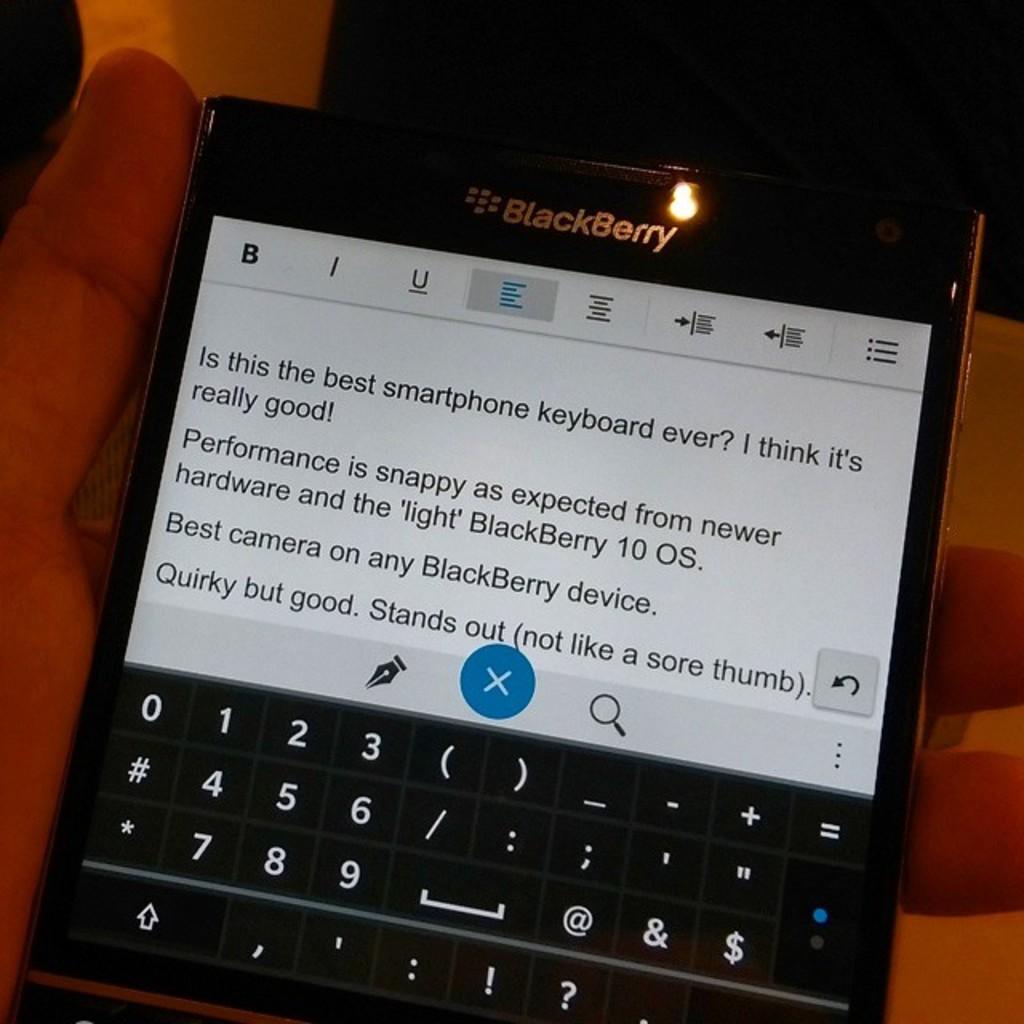What is the brand of this phone?
Your answer should be very brief. Blackberry. What is the last word in the text?
Give a very brief answer. Thumb. 